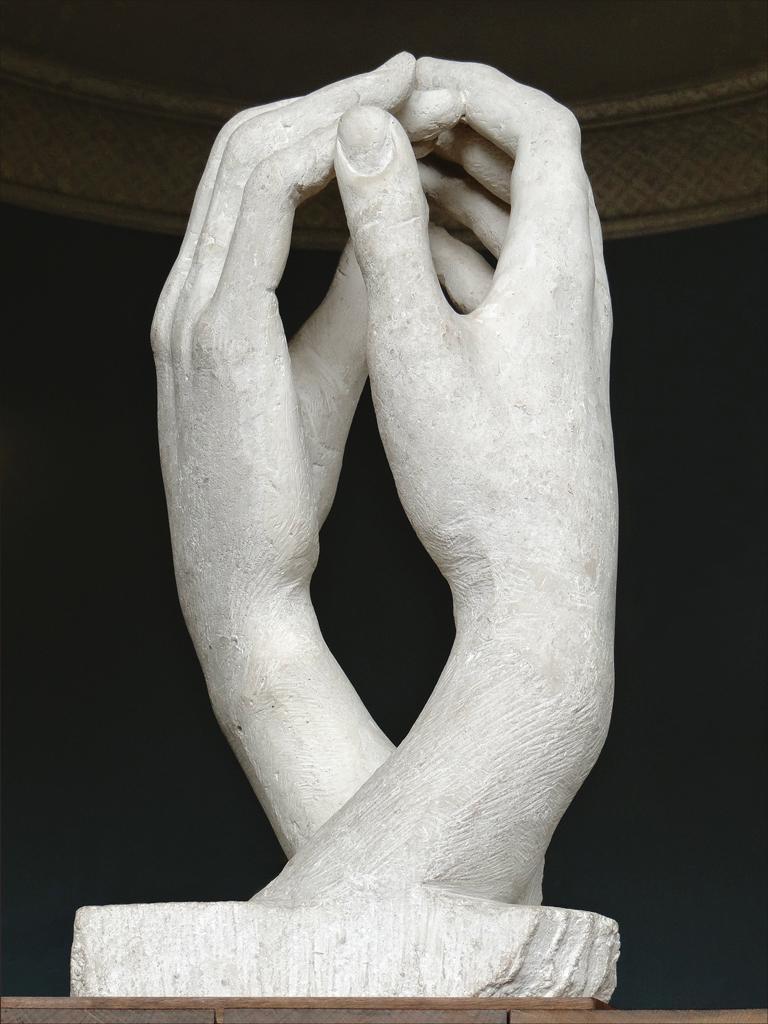In one or two sentences, can you explain what this image depicts? This is a picture of a statue of two hands, and there is dark background. 